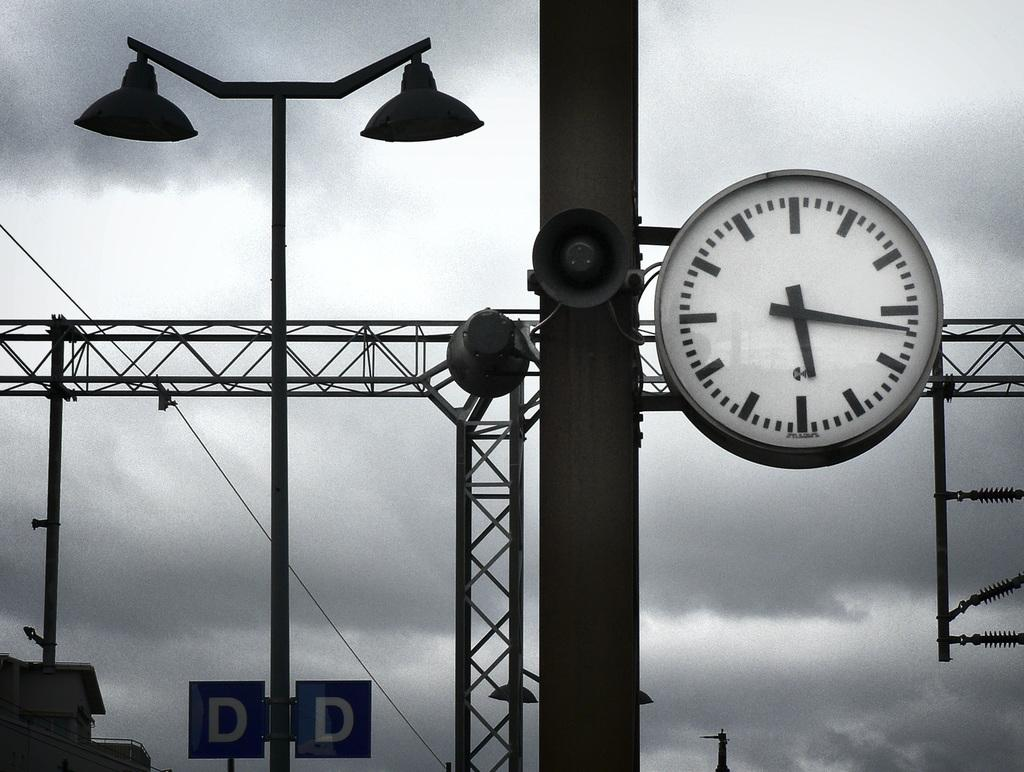Provide a one-sentence caption for the provided image. Structures with a large clock and lights as well as two signs with the letter D. 